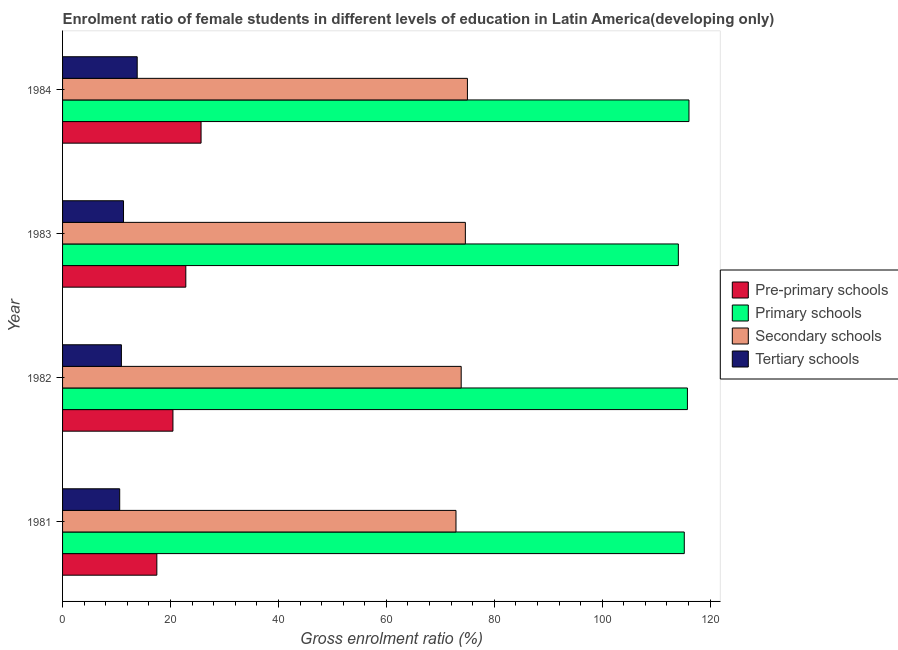In how many cases, is the number of bars for a given year not equal to the number of legend labels?
Keep it short and to the point. 0. What is the gross enrolment ratio(male) in pre-primary schools in 1981?
Ensure brevity in your answer.  17.47. Across all years, what is the maximum gross enrolment ratio(male) in pre-primary schools?
Your response must be concise. 25.66. Across all years, what is the minimum gross enrolment ratio(male) in primary schools?
Give a very brief answer. 114.11. What is the total gross enrolment ratio(male) in secondary schools in the graph?
Provide a succinct answer. 296.44. What is the difference between the gross enrolment ratio(male) in primary schools in 1983 and that in 1984?
Your answer should be very brief. -1.97. What is the difference between the gross enrolment ratio(male) in primary schools in 1983 and the gross enrolment ratio(male) in pre-primary schools in 1984?
Provide a succinct answer. 88.45. What is the average gross enrolment ratio(male) in tertiary schools per year?
Provide a succinct answer. 11.65. In the year 1983, what is the difference between the gross enrolment ratio(male) in pre-primary schools and gross enrolment ratio(male) in primary schools?
Make the answer very short. -91.27. Is the difference between the gross enrolment ratio(male) in primary schools in 1982 and 1984 greater than the difference between the gross enrolment ratio(male) in pre-primary schools in 1982 and 1984?
Give a very brief answer. Yes. What is the difference between the highest and the second highest gross enrolment ratio(male) in primary schools?
Give a very brief answer. 0.29. What is the difference between the highest and the lowest gross enrolment ratio(male) in pre-primary schools?
Provide a succinct answer. 8.19. Is the sum of the gross enrolment ratio(male) in pre-primary schools in 1982 and 1983 greater than the maximum gross enrolment ratio(male) in tertiary schools across all years?
Provide a succinct answer. Yes. Is it the case that in every year, the sum of the gross enrolment ratio(male) in pre-primary schools and gross enrolment ratio(male) in primary schools is greater than the sum of gross enrolment ratio(male) in secondary schools and gross enrolment ratio(male) in tertiary schools?
Your response must be concise. Yes. What does the 4th bar from the top in 1984 represents?
Ensure brevity in your answer.  Pre-primary schools. What does the 2nd bar from the bottom in 1984 represents?
Your answer should be very brief. Primary schools. Is it the case that in every year, the sum of the gross enrolment ratio(male) in pre-primary schools and gross enrolment ratio(male) in primary schools is greater than the gross enrolment ratio(male) in secondary schools?
Ensure brevity in your answer.  Yes. How many years are there in the graph?
Give a very brief answer. 4. Are the values on the major ticks of X-axis written in scientific E-notation?
Your answer should be very brief. No. Does the graph contain any zero values?
Give a very brief answer. No. Where does the legend appear in the graph?
Keep it short and to the point. Center right. How many legend labels are there?
Provide a short and direct response. 4. What is the title of the graph?
Provide a short and direct response. Enrolment ratio of female students in different levels of education in Latin America(developing only). Does "Budget management" appear as one of the legend labels in the graph?
Provide a short and direct response. No. What is the Gross enrolment ratio (%) in Pre-primary schools in 1981?
Offer a terse response. 17.47. What is the Gross enrolment ratio (%) of Primary schools in 1981?
Provide a short and direct response. 115.21. What is the Gross enrolment ratio (%) in Secondary schools in 1981?
Ensure brevity in your answer.  72.9. What is the Gross enrolment ratio (%) in Tertiary schools in 1981?
Offer a terse response. 10.59. What is the Gross enrolment ratio (%) in Pre-primary schools in 1982?
Your answer should be compact. 20.45. What is the Gross enrolment ratio (%) in Primary schools in 1982?
Provide a short and direct response. 115.79. What is the Gross enrolment ratio (%) in Secondary schools in 1982?
Make the answer very short. 73.87. What is the Gross enrolment ratio (%) of Tertiary schools in 1982?
Your answer should be very brief. 10.9. What is the Gross enrolment ratio (%) of Pre-primary schools in 1983?
Give a very brief answer. 22.84. What is the Gross enrolment ratio (%) of Primary schools in 1983?
Make the answer very short. 114.11. What is the Gross enrolment ratio (%) in Secondary schools in 1983?
Make the answer very short. 74.64. What is the Gross enrolment ratio (%) in Tertiary schools in 1983?
Offer a terse response. 11.3. What is the Gross enrolment ratio (%) in Pre-primary schools in 1984?
Offer a terse response. 25.66. What is the Gross enrolment ratio (%) of Primary schools in 1984?
Give a very brief answer. 116.08. What is the Gross enrolment ratio (%) of Secondary schools in 1984?
Provide a short and direct response. 75.02. What is the Gross enrolment ratio (%) in Tertiary schools in 1984?
Ensure brevity in your answer.  13.83. Across all years, what is the maximum Gross enrolment ratio (%) of Pre-primary schools?
Make the answer very short. 25.66. Across all years, what is the maximum Gross enrolment ratio (%) of Primary schools?
Ensure brevity in your answer.  116.08. Across all years, what is the maximum Gross enrolment ratio (%) of Secondary schools?
Provide a short and direct response. 75.02. Across all years, what is the maximum Gross enrolment ratio (%) of Tertiary schools?
Your response must be concise. 13.83. Across all years, what is the minimum Gross enrolment ratio (%) of Pre-primary schools?
Give a very brief answer. 17.47. Across all years, what is the minimum Gross enrolment ratio (%) of Primary schools?
Provide a short and direct response. 114.11. Across all years, what is the minimum Gross enrolment ratio (%) in Secondary schools?
Your response must be concise. 72.9. Across all years, what is the minimum Gross enrolment ratio (%) of Tertiary schools?
Provide a succinct answer. 10.59. What is the total Gross enrolment ratio (%) of Pre-primary schools in the graph?
Ensure brevity in your answer.  86.43. What is the total Gross enrolment ratio (%) of Primary schools in the graph?
Keep it short and to the point. 461.19. What is the total Gross enrolment ratio (%) in Secondary schools in the graph?
Provide a succinct answer. 296.44. What is the total Gross enrolment ratio (%) in Tertiary schools in the graph?
Ensure brevity in your answer.  46.62. What is the difference between the Gross enrolment ratio (%) in Pre-primary schools in 1981 and that in 1982?
Offer a terse response. -2.98. What is the difference between the Gross enrolment ratio (%) in Primary schools in 1981 and that in 1982?
Ensure brevity in your answer.  -0.58. What is the difference between the Gross enrolment ratio (%) of Secondary schools in 1981 and that in 1982?
Keep it short and to the point. -0.96. What is the difference between the Gross enrolment ratio (%) of Tertiary schools in 1981 and that in 1982?
Offer a terse response. -0.31. What is the difference between the Gross enrolment ratio (%) in Pre-primary schools in 1981 and that in 1983?
Give a very brief answer. -5.37. What is the difference between the Gross enrolment ratio (%) of Primary schools in 1981 and that in 1983?
Your answer should be compact. 1.1. What is the difference between the Gross enrolment ratio (%) of Secondary schools in 1981 and that in 1983?
Provide a succinct answer. -1.74. What is the difference between the Gross enrolment ratio (%) of Tertiary schools in 1981 and that in 1983?
Your answer should be compact. -0.71. What is the difference between the Gross enrolment ratio (%) in Pre-primary schools in 1981 and that in 1984?
Offer a very short reply. -8.19. What is the difference between the Gross enrolment ratio (%) of Primary schools in 1981 and that in 1984?
Give a very brief answer. -0.87. What is the difference between the Gross enrolment ratio (%) in Secondary schools in 1981 and that in 1984?
Give a very brief answer. -2.12. What is the difference between the Gross enrolment ratio (%) in Tertiary schools in 1981 and that in 1984?
Offer a terse response. -3.24. What is the difference between the Gross enrolment ratio (%) in Pre-primary schools in 1982 and that in 1983?
Offer a very short reply. -2.39. What is the difference between the Gross enrolment ratio (%) in Primary schools in 1982 and that in 1983?
Keep it short and to the point. 1.68. What is the difference between the Gross enrolment ratio (%) of Secondary schools in 1982 and that in 1983?
Your answer should be compact. -0.77. What is the difference between the Gross enrolment ratio (%) in Tertiary schools in 1982 and that in 1983?
Make the answer very short. -0.39. What is the difference between the Gross enrolment ratio (%) of Pre-primary schools in 1982 and that in 1984?
Give a very brief answer. -5.21. What is the difference between the Gross enrolment ratio (%) in Primary schools in 1982 and that in 1984?
Make the answer very short. -0.29. What is the difference between the Gross enrolment ratio (%) in Secondary schools in 1982 and that in 1984?
Provide a short and direct response. -1.16. What is the difference between the Gross enrolment ratio (%) in Tertiary schools in 1982 and that in 1984?
Provide a succinct answer. -2.93. What is the difference between the Gross enrolment ratio (%) in Pre-primary schools in 1983 and that in 1984?
Give a very brief answer. -2.83. What is the difference between the Gross enrolment ratio (%) in Primary schools in 1983 and that in 1984?
Your response must be concise. -1.97. What is the difference between the Gross enrolment ratio (%) in Secondary schools in 1983 and that in 1984?
Give a very brief answer. -0.38. What is the difference between the Gross enrolment ratio (%) in Tertiary schools in 1983 and that in 1984?
Offer a very short reply. -2.54. What is the difference between the Gross enrolment ratio (%) of Pre-primary schools in 1981 and the Gross enrolment ratio (%) of Primary schools in 1982?
Give a very brief answer. -98.32. What is the difference between the Gross enrolment ratio (%) in Pre-primary schools in 1981 and the Gross enrolment ratio (%) in Secondary schools in 1982?
Make the answer very short. -56.4. What is the difference between the Gross enrolment ratio (%) in Pre-primary schools in 1981 and the Gross enrolment ratio (%) in Tertiary schools in 1982?
Your response must be concise. 6.57. What is the difference between the Gross enrolment ratio (%) of Primary schools in 1981 and the Gross enrolment ratio (%) of Secondary schools in 1982?
Make the answer very short. 41.34. What is the difference between the Gross enrolment ratio (%) of Primary schools in 1981 and the Gross enrolment ratio (%) of Tertiary schools in 1982?
Your answer should be compact. 104.31. What is the difference between the Gross enrolment ratio (%) in Secondary schools in 1981 and the Gross enrolment ratio (%) in Tertiary schools in 1982?
Offer a very short reply. 62. What is the difference between the Gross enrolment ratio (%) of Pre-primary schools in 1981 and the Gross enrolment ratio (%) of Primary schools in 1983?
Make the answer very short. -96.64. What is the difference between the Gross enrolment ratio (%) in Pre-primary schools in 1981 and the Gross enrolment ratio (%) in Secondary schools in 1983?
Make the answer very short. -57.17. What is the difference between the Gross enrolment ratio (%) of Pre-primary schools in 1981 and the Gross enrolment ratio (%) of Tertiary schools in 1983?
Your answer should be very brief. 6.18. What is the difference between the Gross enrolment ratio (%) in Primary schools in 1981 and the Gross enrolment ratio (%) in Secondary schools in 1983?
Your answer should be very brief. 40.57. What is the difference between the Gross enrolment ratio (%) in Primary schools in 1981 and the Gross enrolment ratio (%) in Tertiary schools in 1983?
Make the answer very short. 103.91. What is the difference between the Gross enrolment ratio (%) of Secondary schools in 1981 and the Gross enrolment ratio (%) of Tertiary schools in 1983?
Your answer should be compact. 61.61. What is the difference between the Gross enrolment ratio (%) in Pre-primary schools in 1981 and the Gross enrolment ratio (%) in Primary schools in 1984?
Ensure brevity in your answer.  -98.61. What is the difference between the Gross enrolment ratio (%) in Pre-primary schools in 1981 and the Gross enrolment ratio (%) in Secondary schools in 1984?
Ensure brevity in your answer.  -57.55. What is the difference between the Gross enrolment ratio (%) of Pre-primary schools in 1981 and the Gross enrolment ratio (%) of Tertiary schools in 1984?
Your answer should be very brief. 3.64. What is the difference between the Gross enrolment ratio (%) of Primary schools in 1981 and the Gross enrolment ratio (%) of Secondary schools in 1984?
Keep it short and to the point. 40.19. What is the difference between the Gross enrolment ratio (%) of Primary schools in 1981 and the Gross enrolment ratio (%) of Tertiary schools in 1984?
Offer a very short reply. 101.38. What is the difference between the Gross enrolment ratio (%) in Secondary schools in 1981 and the Gross enrolment ratio (%) in Tertiary schools in 1984?
Offer a terse response. 59.07. What is the difference between the Gross enrolment ratio (%) of Pre-primary schools in 1982 and the Gross enrolment ratio (%) of Primary schools in 1983?
Keep it short and to the point. -93.66. What is the difference between the Gross enrolment ratio (%) in Pre-primary schools in 1982 and the Gross enrolment ratio (%) in Secondary schools in 1983?
Your answer should be compact. -54.19. What is the difference between the Gross enrolment ratio (%) of Pre-primary schools in 1982 and the Gross enrolment ratio (%) of Tertiary schools in 1983?
Provide a short and direct response. 9.16. What is the difference between the Gross enrolment ratio (%) in Primary schools in 1982 and the Gross enrolment ratio (%) in Secondary schools in 1983?
Offer a terse response. 41.15. What is the difference between the Gross enrolment ratio (%) in Primary schools in 1982 and the Gross enrolment ratio (%) in Tertiary schools in 1983?
Provide a succinct answer. 104.5. What is the difference between the Gross enrolment ratio (%) of Secondary schools in 1982 and the Gross enrolment ratio (%) of Tertiary schools in 1983?
Provide a short and direct response. 62.57. What is the difference between the Gross enrolment ratio (%) in Pre-primary schools in 1982 and the Gross enrolment ratio (%) in Primary schools in 1984?
Provide a short and direct response. -95.62. What is the difference between the Gross enrolment ratio (%) in Pre-primary schools in 1982 and the Gross enrolment ratio (%) in Secondary schools in 1984?
Your answer should be compact. -54.57. What is the difference between the Gross enrolment ratio (%) in Pre-primary schools in 1982 and the Gross enrolment ratio (%) in Tertiary schools in 1984?
Offer a terse response. 6.62. What is the difference between the Gross enrolment ratio (%) of Primary schools in 1982 and the Gross enrolment ratio (%) of Secondary schools in 1984?
Offer a very short reply. 40.77. What is the difference between the Gross enrolment ratio (%) of Primary schools in 1982 and the Gross enrolment ratio (%) of Tertiary schools in 1984?
Your answer should be very brief. 101.96. What is the difference between the Gross enrolment ratio (%) in Secondary schools in 1982 and the Gross enrolment ratio (%) in Tertiary schools in 1984?
Ensure brevity in your answer.  60.04. What is the difference between the Gross enrolment ratio (%) of Pre-primary schools in 1983 and the Gross enrolment ratio (%) of Primary schools in 1984?
Provide a succinct answer. -93.24. What is the difference between the Gross enrolment ratio (%) of Pre-primary schools in 1983 and the Gross enrolment ratio (%) of Secondary schools in 1984?
Keep it short and to the point. -52.18. What is the difference between the Gross enrolment ratio (%) in Pre-primary schools in 1983 and the Gross enrolment ratio (%) in Tertiary schools in 1984?
Provide a short and direct response. 9.01. What is the difference between the Gross enrolment ratio (%) in Primary schools in 1983 and the Gross enrolment ratio (%) in Secondary schools in 1984?
Offer a very short reply. 39.09. What is the difference between the Gross enrolment ratio (%) of Primary schools in 1983 and the Gross enrolment ratio (%) of Tertiary schools in 1984?
Provide a succinct answer. 100.28. What is the difference between the Gross enrolment ratio (%) of Secondary schools in 1983 and the Gross enrolment ratio (%) of Tertiary schools in 1984?
Ensure brevity in your answer.  60.81. What is the average Gross enrolment ratio (%) in Pre-primary schools per year?
Keep it short and to the point. 21.61. What is the average Gross enrolment ratio (%) of Primary schools per year?
Provide a short and direct response. 115.3. What is the average Gross enrolment ratio (%) in Secondary schools per year?
Make the answer very short. 74.11. What is the average Gross enrolment ratio (%) in Tertiary schools per year?
Provide a succinct answer. 11.65. In the year 1981, what is the difference between the Gross enrolment ratio (%) of Pre-primary schools and Gross enrolment ratio (%) of Primary schools?
Keep it short and to the point. -97.74. In the year 1981, what is the difference between the Gross enrolment ratio (%) in Pre-primary schools and Gross enrolment ratio (%) in Secondary schools?
Ensure brevity in your answer.  -55.43. In the year 1981, what is the difference between the Gross enrolment ratio (%) of Pre-primary schools and Gross enrolment ratio (%) of Tertiary schools?
Keep it short and to the point. 6.88. In the year 1981, what is the difference between the Gross enrolment ratio (%) in Primary schools and Gross enrolment ratio (%) in Secondary schools?
Offer a very short reply. 42.3. In the year 1981, what is the difference between the Gross enrolment ratio (%) of Primary schools and Gross enrolment ratio (%) of Tertiary schools?
Your answer should be compact. 104.62. In the year 1981, what is the difference between the Gross enrolment ratio (%) of Secondary schools and Gross enrolment ratio (%) of Tertiary schools?
Your answer should be compact. 62.32. In the year 1982, what is the difference between the Gross enrolment ratio (%) of Pre-primary schools and Gross enrolment ratio (%) of Primary schools?
Make the answer very short. -95.34. In the year 1982, what is the difference between the Gross enrolment ratio (%) in Pre-primary schools and Gross enrolment ratio (%) in Secondary schools?
Offer a very short reply. -53.41. In the year 1982, what is the difference between the Gross enrolment ratio (%) of Pre-primary schools and Gross enrolment ratio (%) of Tertiary schools?
Make the answer very short. 9.55. In the year 1982, what is the difference between the Gross enrolment ratio (%) in Primary schools and Gross enrolment ratio (%) in Secondary schools?
Your response must be concise. 41.92. In the year 1982, what is the difference between the Gross enrolment ratio (%) of Primary schools and Gross enrolment ratio (%) of Tertiary schools?
Make the answer very short. 104.89. In the year 1982, what is the difference between the Gross enrolment ratio (%) in Secondary schools and Gross enrolment ratio (%) in Tertiary schools?
Ensure brevity in your answer.  62.97. In the year 1983, what is the difference between the Gross enrolment ratio (%) in Pre-primary schools and Gross enrolment ratio (%) in Primary schools?
Ensure brevity in your answer.  -91.27. In the year 1983, what is the difference between the Gross enrolment ratio (%) in Pre-primary schools and Gross enrolment ratio (%) in Secondary schools?
Provide a short and direct response. -51.8. In the year 1983, what is the difference between the Gross enrolment ratio (%) in Pre-primary schools and Gross enrolment ratio (%) in Tertiary schools?
Your answer should be very brief. 11.54. In the year 1983, what is the difference between the Gross enrolment ratio (%) in Primary schools and Gross enrolment ratio (%) in Secondary schools?
Keep it short and to the point. 39.47. In the year 1983, what is the difference between the Gross enrolment ratio (%) of Primary schools and Gross enrolment ratio (%) of Tertiary schools?
Ensure brevity in your answer.  102.81. In the year 1983, what is the difference between the Gross enrolment ratio (%) of Secondary schools and Gross enrolment ratio (%) of Tertiary schools?
Provide a short and direct response. 63.35. In the year 1984, what is the difference between the Gross enrolment ratio (%) in Pre-primary schools and Gross enrolment ratio (%) in Primary schools?
Provide a short and direct response. -90.41. In the year 1984, what is the difference between the Gross enrolment ratio (%) of Pre-primary schools and Gross enrolment ratio (%) of Secondary schools?
Give a very brief answer. -49.36. In the year 1984, what is the difference between the Gross enrolment ratio (%) of Pre-primary schools and Gross enrolment ratio (%) of Tertiary schools?
Offer a very short reply. 11.83. In the year 1984, what is the difference between the Gross enrolment ratio (%) of Primary schools and Gross enrolment ratio (%) of Secondary schools?
Offer a terse response. 41.05. In the year 1984, what is the difference between the Gross enrolment ratio (%) in Primary schools and Gross enrolment ratio (%) in Tertiary schools?
Your answer should be very brief. 102.25. In the year 1984, what is the difference between the Gross enrolment ratio (%) of Secondary schools and Gross enrolment ratio (%) of Tertiary schools?
Your answer should be compact. 61.19. What is the ratio of the Gross enrolment ratio (%) in Pre-primary schools in 1981 to that in 1982?
Provide a succinct answer. 0.85. What is the ratio of the Gross enrolment ratio (%) in Secondary schools in 1981 to that in 1982?
Give a very brief answer. 0.99. What is the ratio of the Gross enrolment ratio (%) in Tertiary schools in 1981 to that in 1982?
Your response must be concise. 0.97. What is the ratio of the Gross enrolment ratio (%) of Pre-primary schools in 1981 to that in 1983?
Your response must be concise. 0.77. What is the ratio of the Gross enrolment ratio (%) of Primary schools in 1981 to that in 1983?
Your answer should be very brief. 1.01. What is the ratio of the Gross enrolment ratio (%) in Secondary schools in 1981 to that in 1983?
Ensure brevity in your answer.  0.98. What is the ratio of the Gross enrolment ratio (%) in Pre-primary schools in 1981 to that in 1984?
Your response must be concise. 0.68. What is the ratio of the Gross enrolment ratio (%) of Secondary schools in 1981 to that in 1984?
Offer a very short reply. 0.97. What is the ratio of the Gross enrolment ratio (%) in Tertiary schools in 1981 to that in 1984?
Keep it short and to the point. 0.77. What is the ratio of the Gross enrolment ratio (%) in Pre-primary schools in 1982 to that in 1983?
Provide a short and direct response. 0.9. What is the ratio of the Gross enrolment ratio (%) of Primary schools in 1982 to that in 1983?
Offer a terse response. 1.01. What is the ratio of the Gross enrolment ratio (%) of Secondary schools in 1982 to that in 1983?
Give a very brief answer. 0.99. What is the ratio of the Gross enrolment ratio (%) in Tertiary schools in 1982 to that in 1983?
Your answer should be very brief. 0.97. What is the ratio of the Gross enrolment ratio (%) in Pre-primary schools in 1982 to that in 1984?
Ensure brevity in your answer.  0.8. What is the ratio of the Gross enrolment ratio (%) of Secondary schools in 1982 to that in 1984?
Give a very brief answer. 0.98. What is the ratio of the Gross enrolment ratio (%) in Tertiary schools in 1982 to that in 1984?
Give a very brief answer. 0.79. What is the ratio of the Gross enrolment ratio (%) in Pre-primary schools in 1983 to that in 1984?
Offer a terse response. 0.89. What is the ratio of the Gross enrolment ratio (%) of Secondary schools in 1983 to that in 1984?
Offer a very short reply. 0.99. What is the ratio of the Gross enrolment ratio (%) of Tertiary schools in 1983 to that in 1984?
Your answer should be very brief. 0.82. What is the difference between the highest and the second highest Gross enrolment ratio (%) in Pre-primary schools?
Your response must be concise. 2.83. What is the difference between the highest and the second highest Gross enrolment ratio (%) in Primary schools?
Make the answer very short. 0.29. What is the difference between the highest and the second highest Gross enrolment ratio (%) in Secondary schools?
Provide a succinct answer. 0.38. What is the difference between the highest and the second highest Gross enrolment ratio (%) in Tertiary schools?
Provide a short and direct response. 2.54. What is the difference between the highest and the lowest Gross enrolment ratio (%) in Pre-primary schools?
Your response must be concise. 8.19. What is the difference between the highest and the lowest Gross enrolment ratio (%) in Primary schools?
Your answer should be very brief. 1.97. What is the difference between the highest and the lowest Gross enrolment ratio (%) in Secondary schools?
Offer a terse response. 2.12. What is the difference between the highest and the lowest Gross enrolment ratio (%) of Tertiary schools?
Keep it short and to the point. 3.24. 